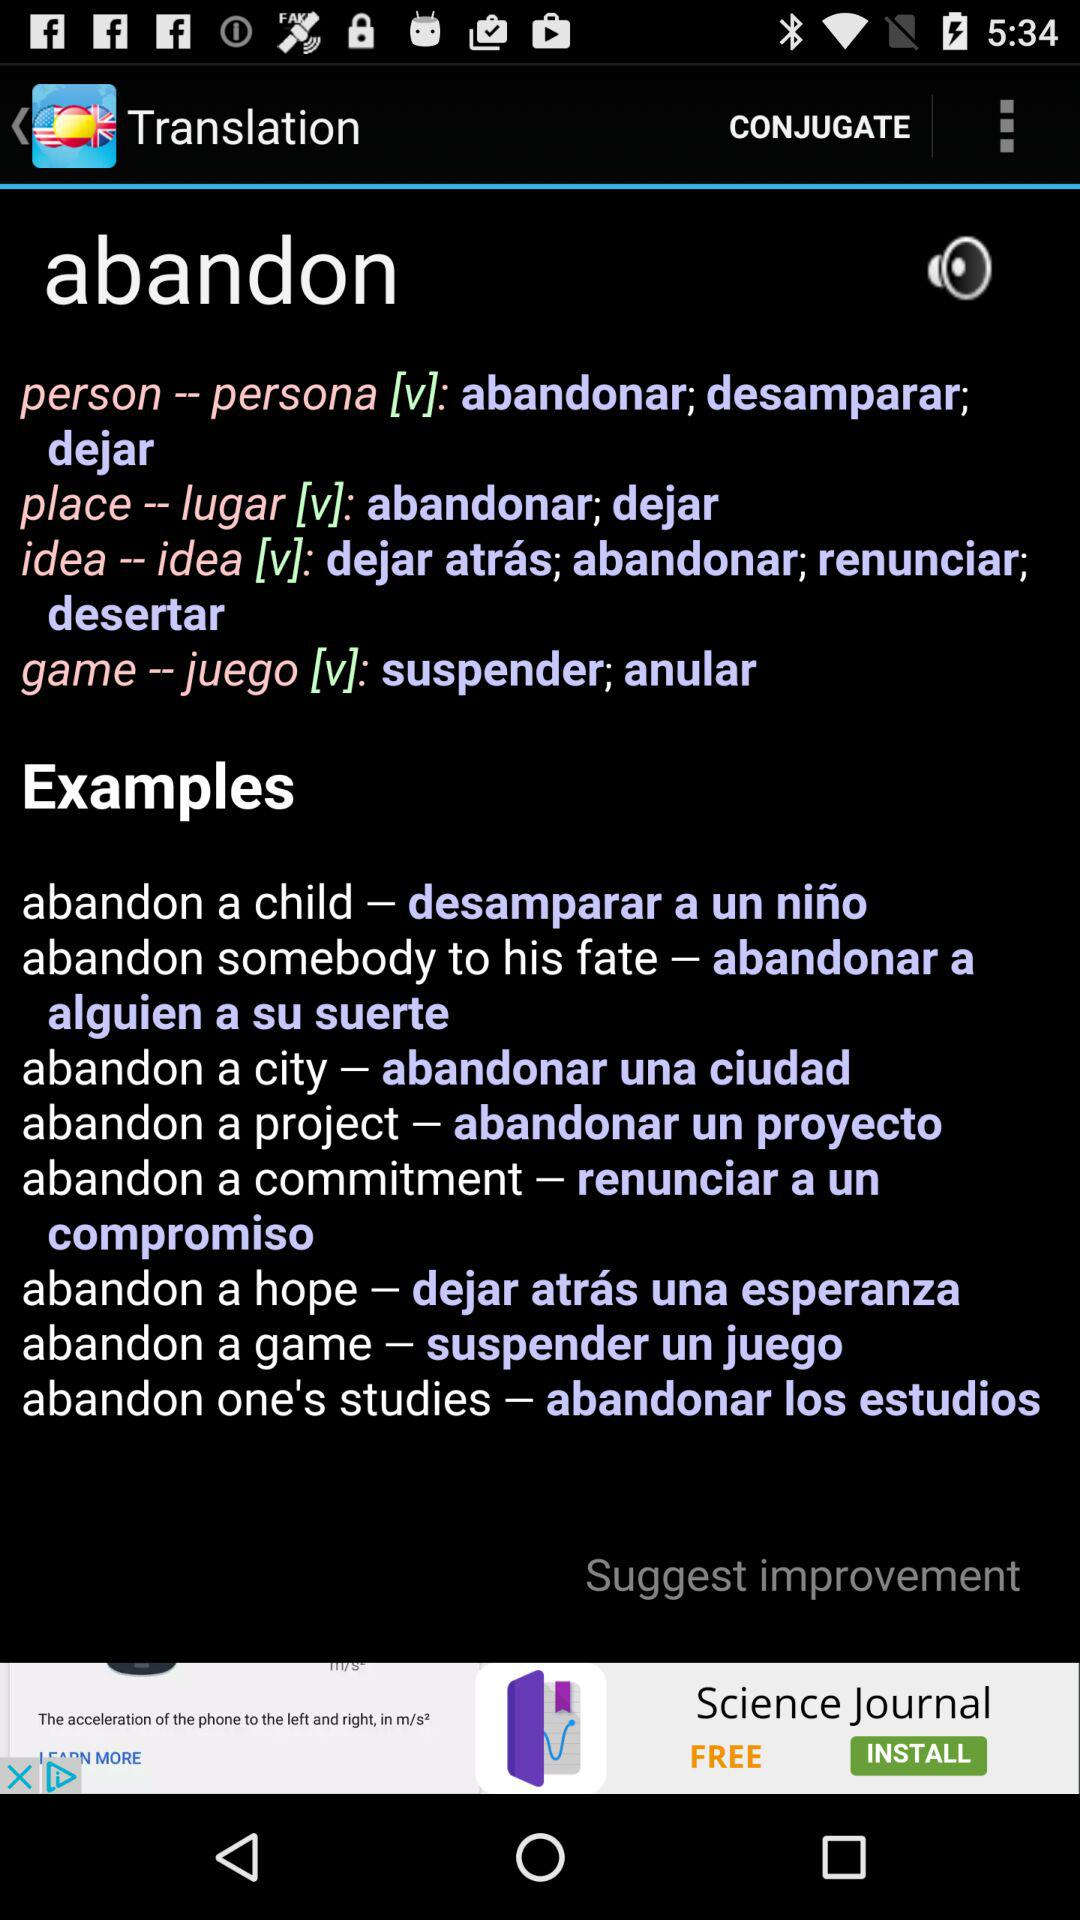What is the name of the application? The name of the application is "Spanish English Dictionary". 